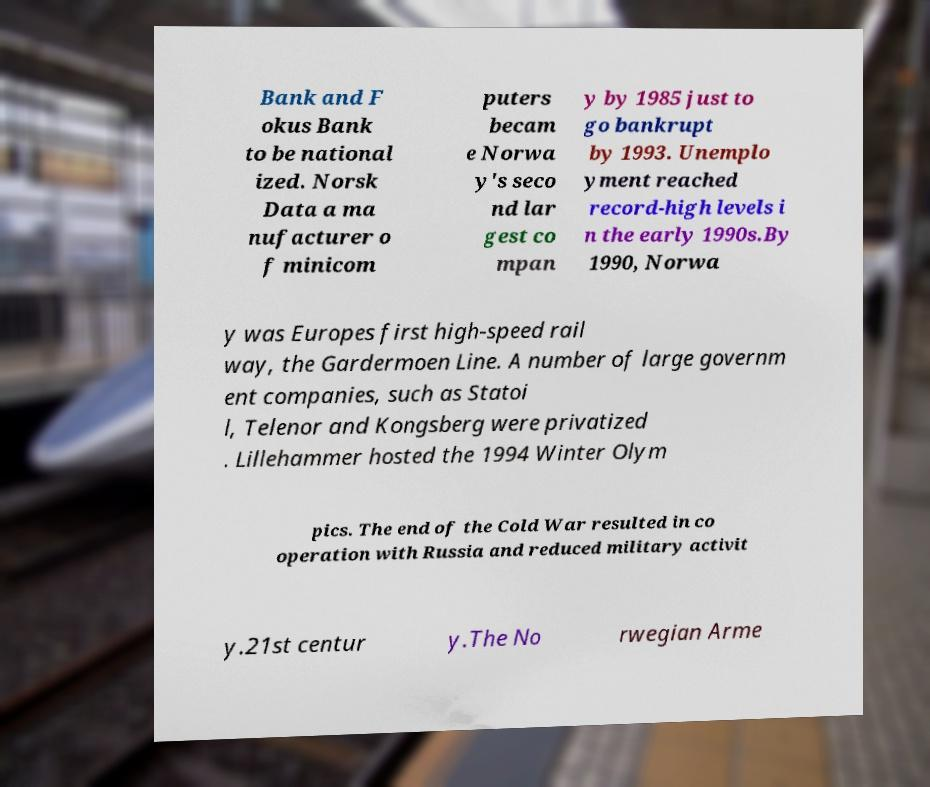What messages or text are displayed in this image? I need them in a readable, typed format. Bank and F okus Bank to be national ized. Norsk Data a ma nufacturer o f minicom puters becam e Norwa y's seco nd lar gest co mpan y by 1985 just to go bankrupt by 1993. Unemplo yment reached record-high levels i n the early 1990s.By 1990, Norwa y was Europes first high-speed rail way, the Gardermoen Line. A number of large governm ent companies, such as Statoi l, Telenor and Kongsberg were privatized . Lillehammer hosted the 1994 Winter Olym pics. The end of the Cold War resulted in co operation with Russia and reduced military activit y.21st centur y.The No rwegian Arme 